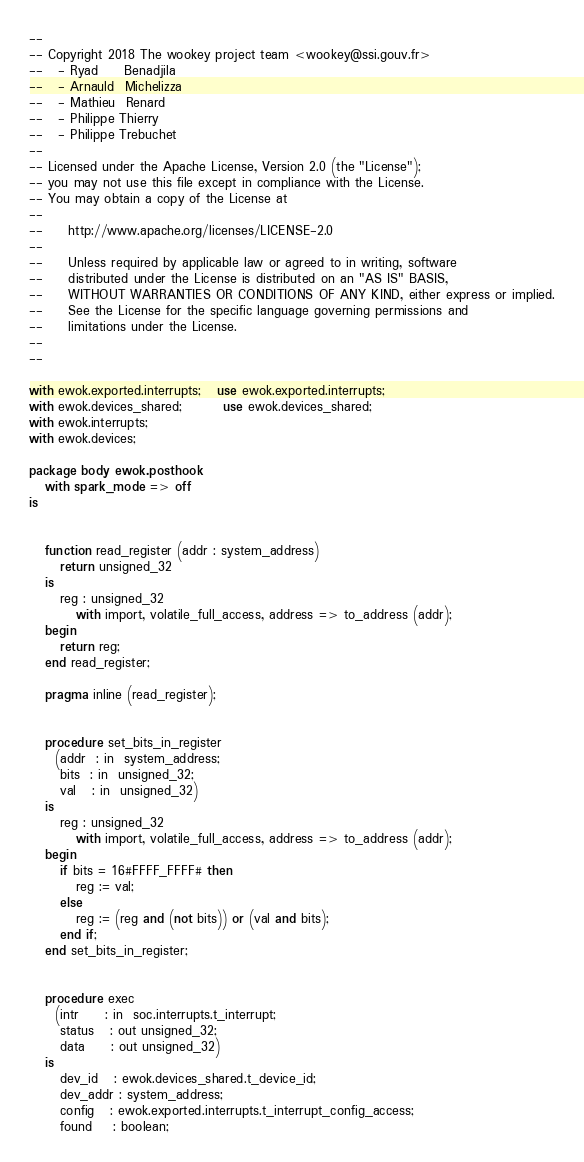Convert code to text. <code><loc_0><loc_0><loc_500><loc_500><_Ada_>--
-- Copyright 2018 The wookey project team <wookey@ssi.gouv.fr>
--   - Ryad     Benadjila
--   - Arnauld  Michelizza
--   - Mathieu  Renard
--   - Philippe Thierry
--   - Philippe Trebuchet
--
-- Licensed under the Apache License, Version 2.0 (the "License");
-- you may not use this file except in compliance with the License.
-- You may obtain a copy of the License at
--
--     http://www.apache.org/licenses/LICENSE-2.0
--
--     Unless required by applicable law or agreed to in writing, software
--     distributed under the License is distributed on an "AS IS" BASIS,
--     WITHOUT WARRANTIES OR CONDITIONS OF ANY KIND, either express or implied.
--     See the License for the specific language governing permissions and
--     limitations under the License.
--
--

with ewok.exported.interrupts;   use ewok.exported.interrupts;
with ewok.devices_shared;        use ewok.devices_shared;
with ewok.interrupts;
with ewok.devices;

package body ewok.posthook
   with spark_mode => off
is


   function read_register (addr : system_address)
      return unsigned_32
   is
      reg : unsigned_32
         with import, volatile_full_access, address => to_address (addr);
   begin
      return reg;
   end read_register;

   pragma inline (read_register);


   procedure set_bits_in_register
     (addr  : in  system_address;
      bits  : in  unsigned_32;
      val   : in  unsigned_32)
   is
      reg : unsigned_32
         with import, volatile_full_access, address => to_address (addr);
   begin
      if bits = 16#FFFF_FFFF# then
         reg := val;
      else
         reg := (reg and (not bits)) or (val and bits);
      end if;
   end set_bits_in_register;


   procedure exec
     (intr     : in  soc.interrupts.t_interrupt;
      status   : out unsigned_32;
      data     : out unsigned_32)
   is
      dev_id   : ewok.devices_shared.t_device_id;
      dev_addr : system_address;
      config   : ewok.exported.interrupts.t_interrupt_config_access;
      found    : boolean;</code> 